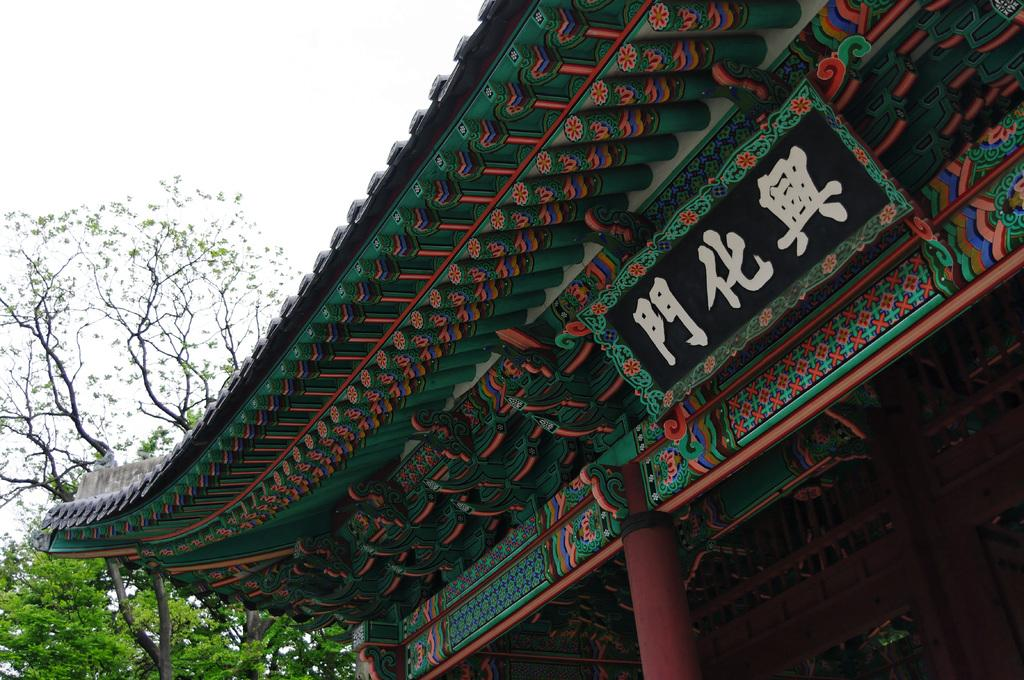What is featured on the ancient architecture in the image? There is text on an ancient architecture in the image. What can be seen on the left side of the image? There are trees visible on the left side of the image. What type of crime is being committed in the image? There is no crime being committed in the image; it features text on an ancient architecture and trees on the left side. How many clovers can be seen in the image? There are no clovers present in the image. 